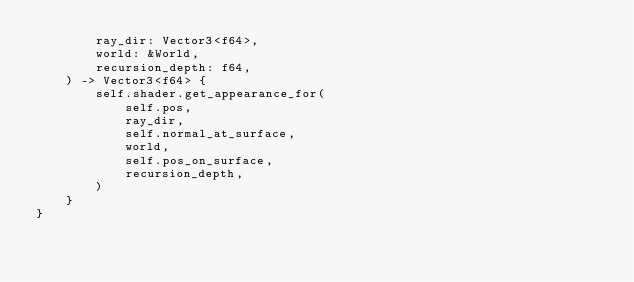<code> <loc_0><loc_0><loc_500><loc_500><_Rust_>        ray_dir: Vector3<f64>,
        world: &World,
        recursion_depth: f64,
    ) -> Vector3<f64> {
        self.shader.get_appearance_for(
            self.pos,
            ray_dir,
            self.normal_at_surface,
            world,
            self.pos_on_surface,
            recursion_depth,
        )
    }
}
</code> 